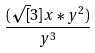<formula> <loc_0><loc_0><loc_500><loc_500>\frac { ( \sqrt { [ } 3 ] { x * y ^ { 2 } ) } } { y ^ { 3 } }</formula> 